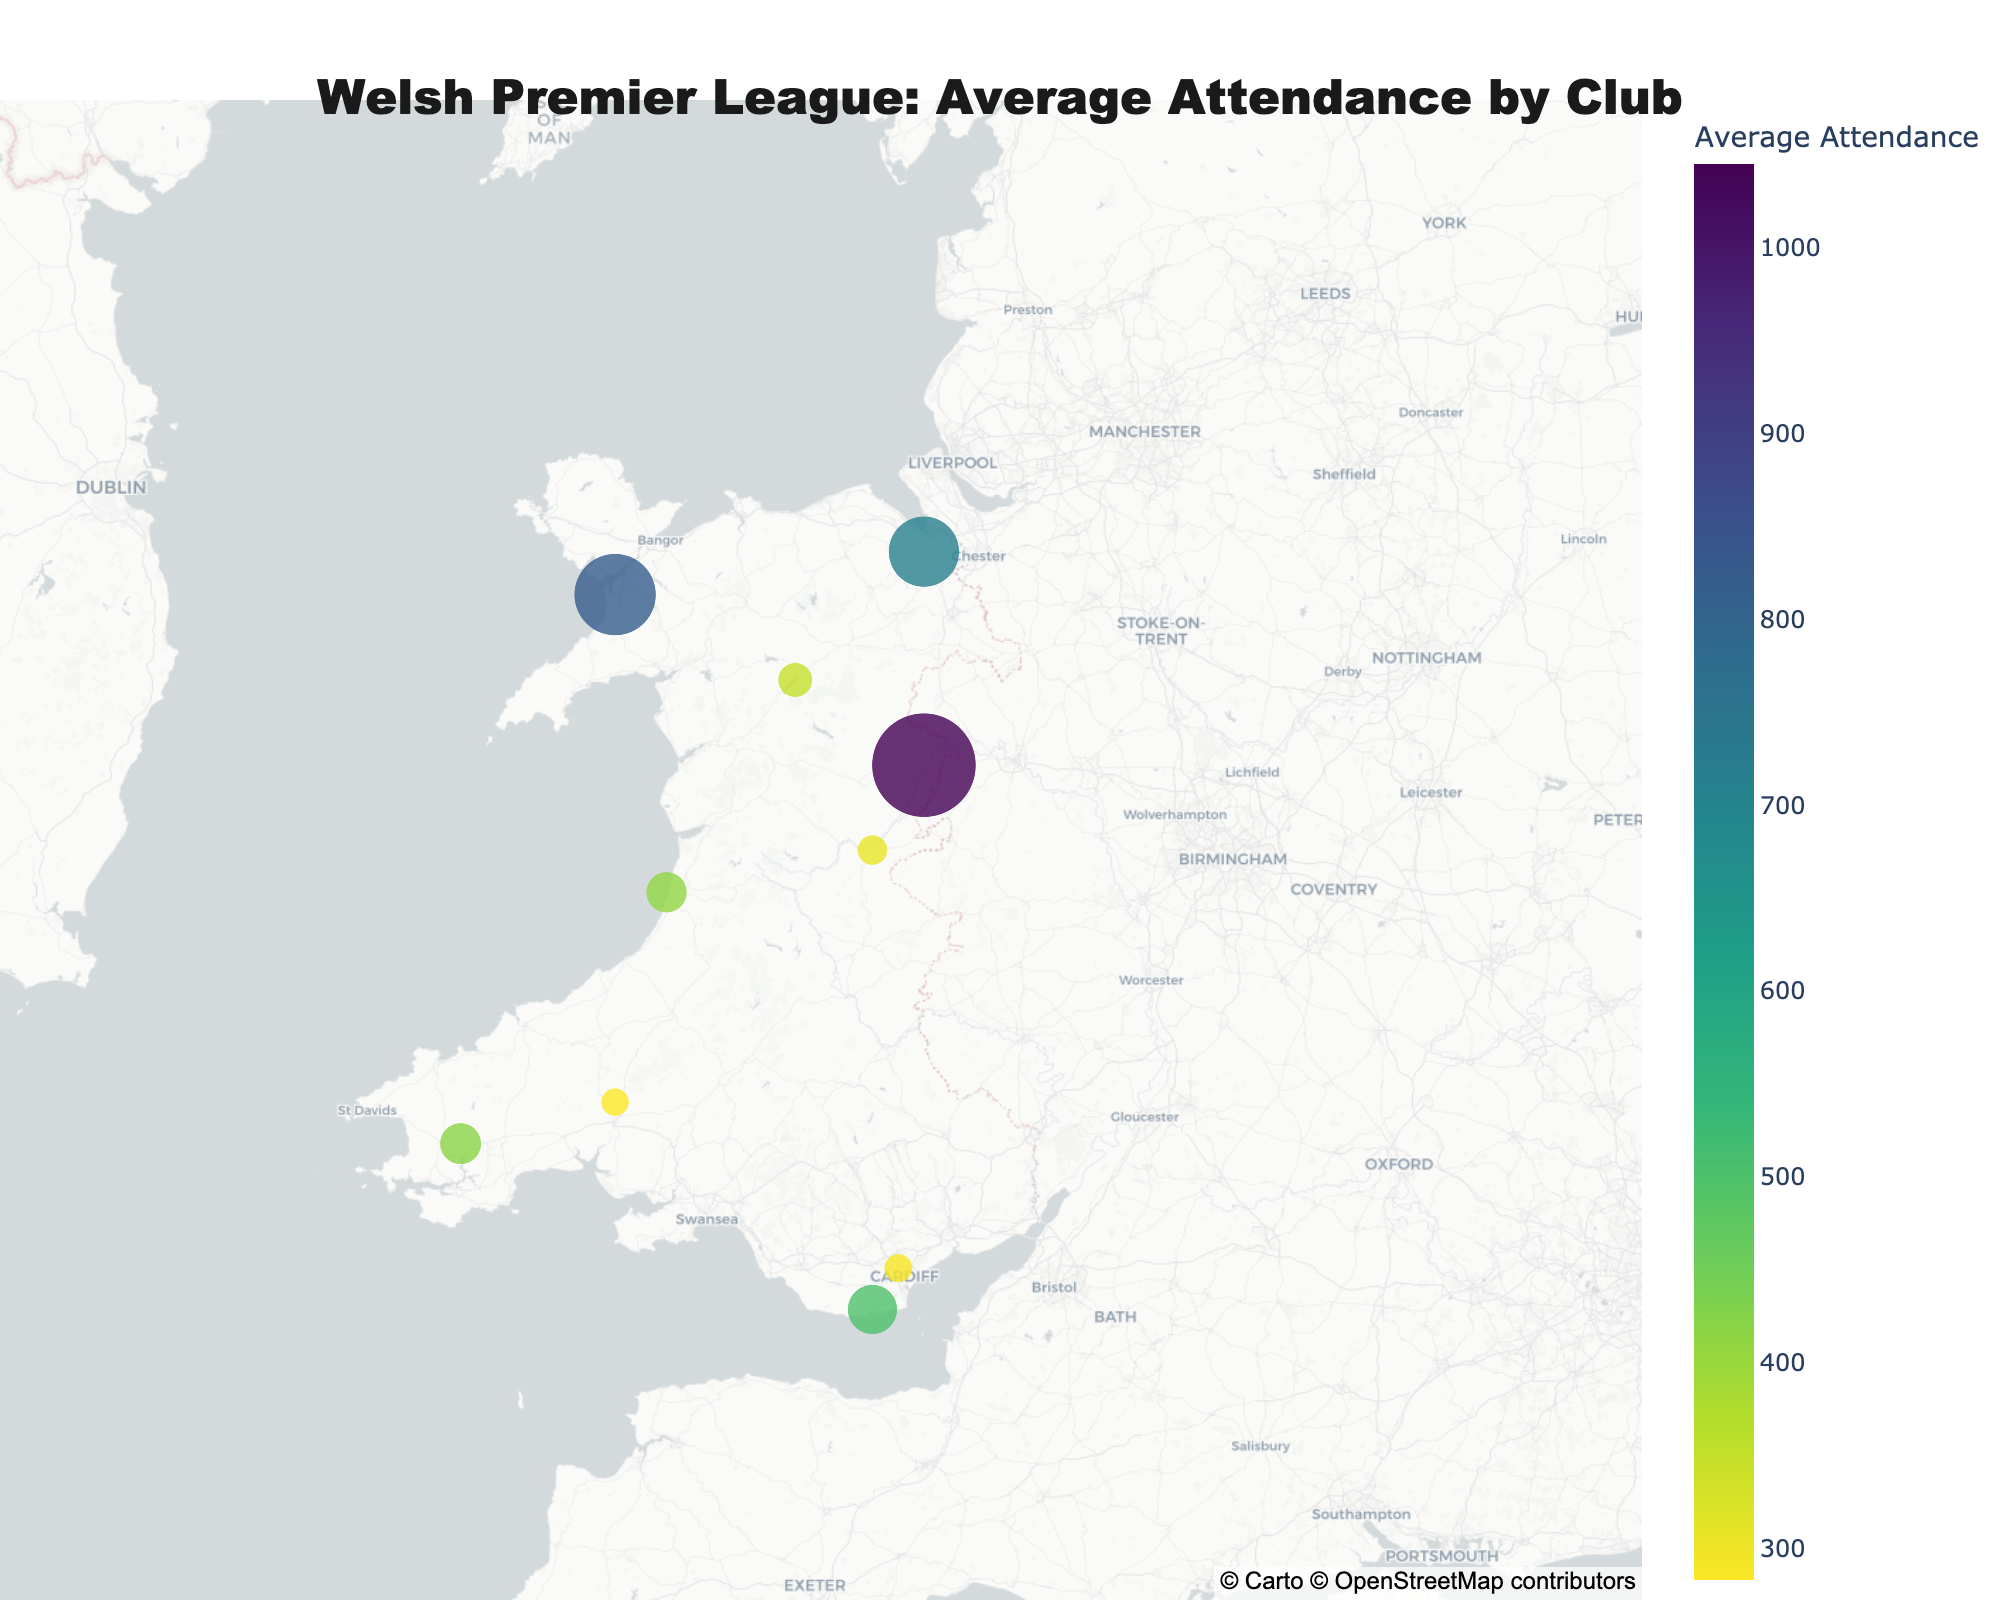How many clubs are represented in the plot? Count all the data points (clubs) on the map. There are 10 clubs in the data.
Answer: 10 Which club has the highest average attendance? Look for the largest marker on the map and check the color scale for confirmation. The New Saints has the highest average attendance of 1045.
Answer: The New Saints What's the average attendance of the clubs located in Central Wales? Add the attendance figures for Newtown AFC (305) and Aberystwyth Town (412), then divide by 2. (305 + 412) / 2 = 358.5
Answer: 358.5 Which region has the most clubs represented? Count the number of clubs for each region: North Wales (3), Central Wales (2), South West Wales (2), South East Wales (3). North Wales and South East Wales have the most clubs with 3 each.
Answer: North Wales & South East Wales Which club is located furthest south-west on the map? Check the club with the most southwestern position on the map, which involves both latitude (south) and longitude (west). Haverfordwest County is the furthest southwest.
Answer: Haverfordwest County What is the total average attendance for all clubs in North Wales? Sum the attendance figures for Connah's Quay Nomads (712), Caernarfon Town (823), and Bala Town (348). 712 + 823 + 348 = 1883
Answer: 1883 Compare the average attendances of Barry Town United and Cardiff Metropolitan University. Which is higher? Refer to the attendance figures for both clubs: Barry Town United (502) and Cardiff Metropolitan University (289). Barry Town United has a higher average attendance.
Answer: Barry Town United What's the average attendance for clubs in South East Wales? Add the attendance figures for The New Saints (1045), Cardiff Metropolitan University (289), and Barry Town United (502), then divide by 3. (1045 + 289 + 502) / 3 = 612
Answer: 612 What is the average attendance difference between Connah's Quay Nomads and Caernarfon Town? Subtract the attendance of Connah's Quay Nomads (712) from Caernarfon Town (823). 823 - 712 = 111
Answer: 111 Which club marker is the largest on the plot? The size of the marker is proportional to the average attendance. The New Saints has the largest marker.
Answer: The New Saints 